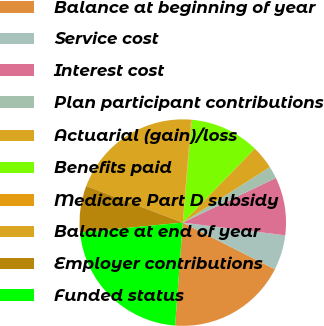Convert chart. <chart><loc_0><loc_0><loc_500><loc_500><pie_chart><fcel>Balance at beginning of year<fcel>Service cost<fcel>Interest cost<fcel>Plan participant contributions<fcel>Actuarial (gain)/loss<fcel>Benefits paid<fcel>Medicare Part D subsidy<fcel>Balance at end of year<fcel>Employer contributions<fcel>Funded status<nl><fcel>18.72%<fcel>5.5%<fcel>9.08%<fcel>1.91%<fcel>3.7%<fcel>10.88%<fcel>0.11%<fcel>20.51%<fcel>7.29%<fcel>22.3%<nl></chart> 